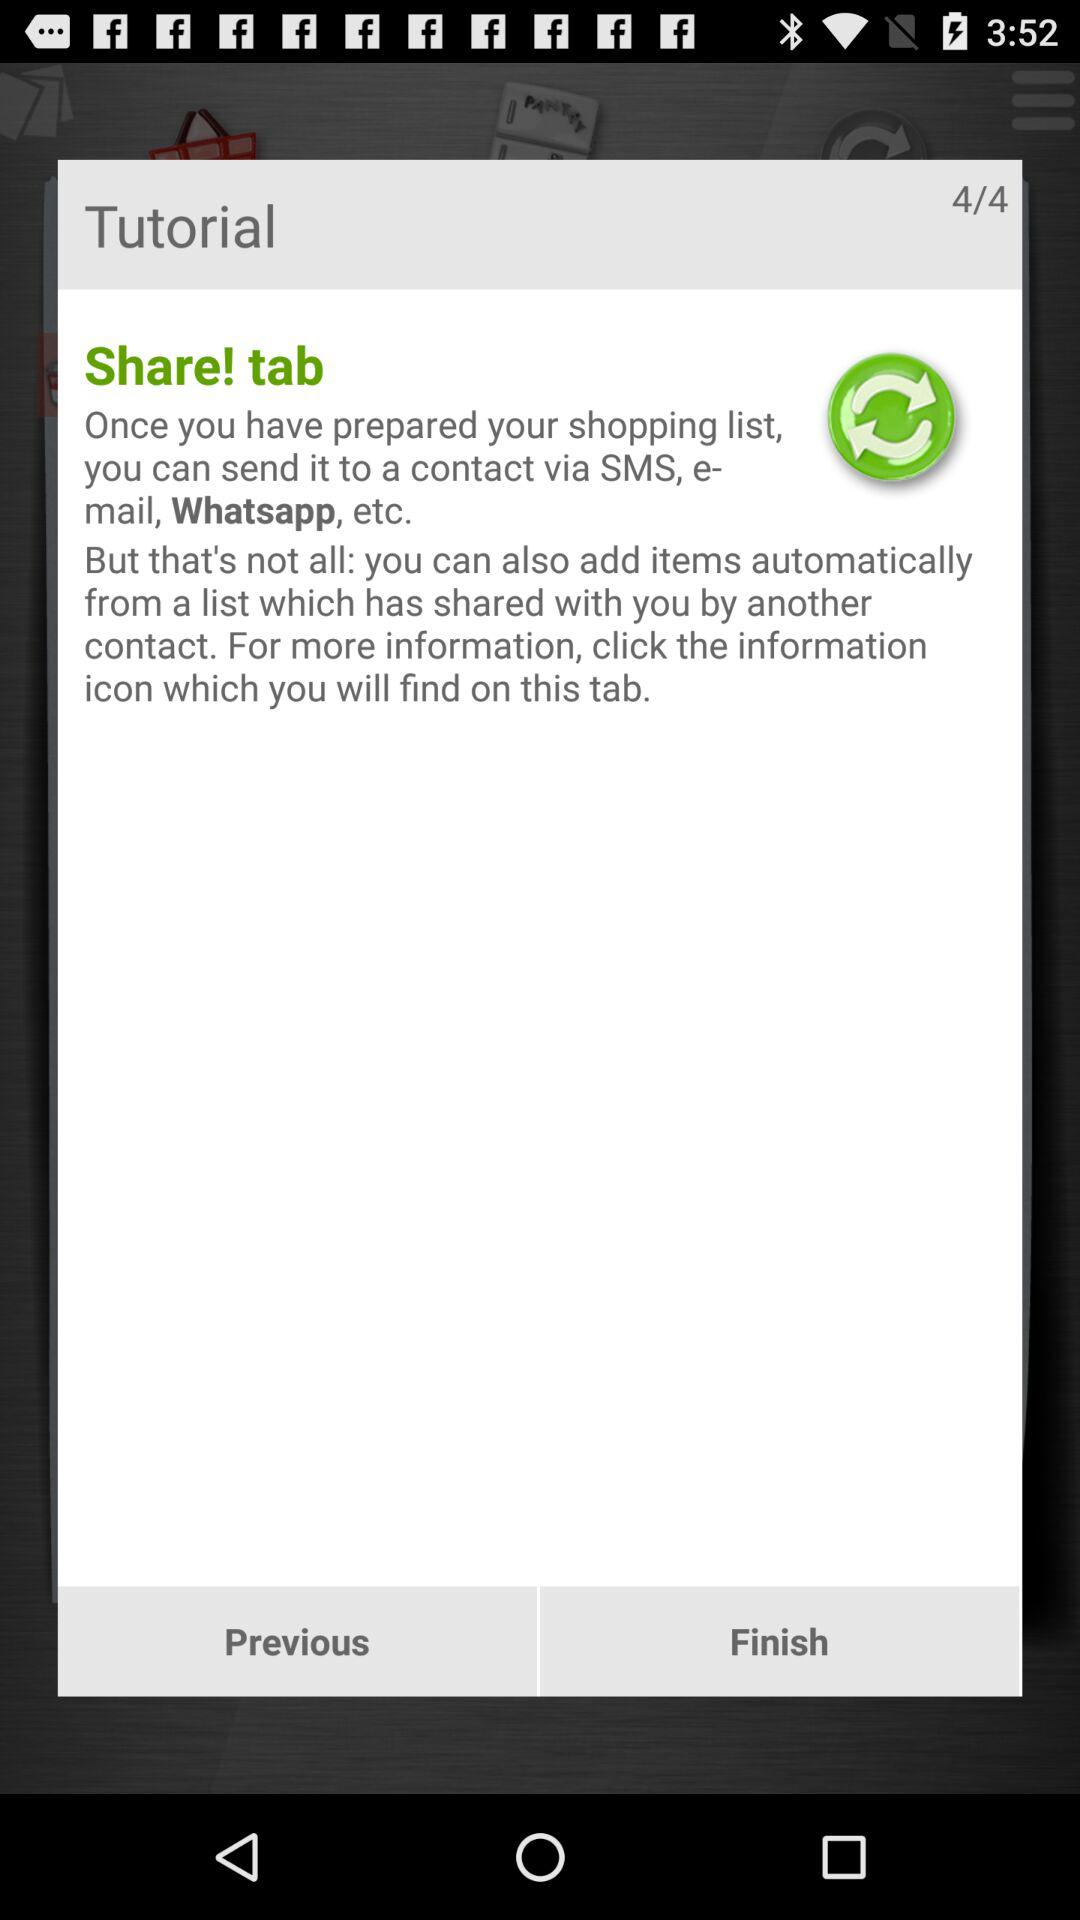How many steps are there in the tutorial?
Answer the question using a single word or phrase. 4 